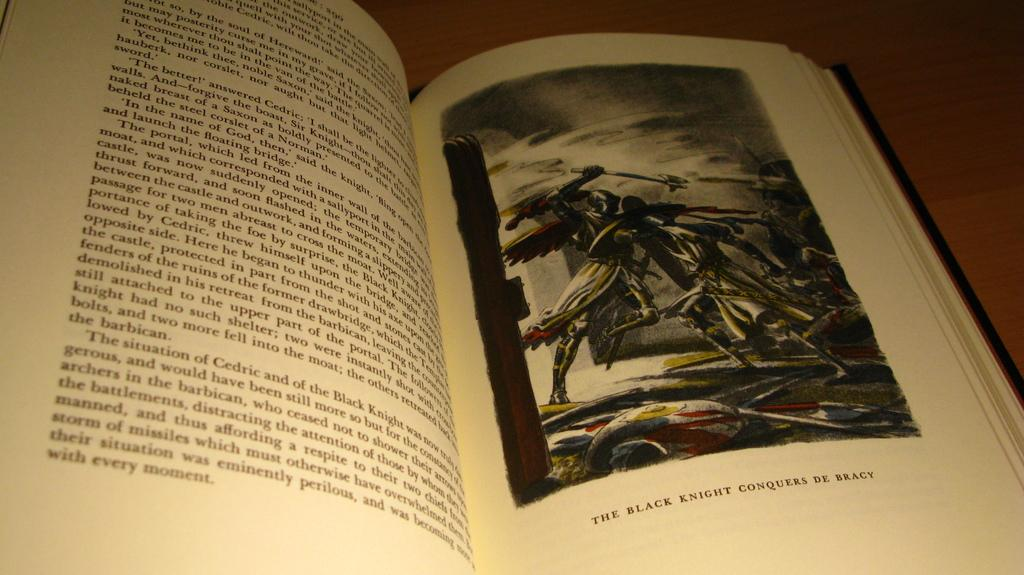<image>
Relay a brief, clear account of the picture shown. A book opened to a page with a title of an image saying the Black Knight Conquered De Bracy. 